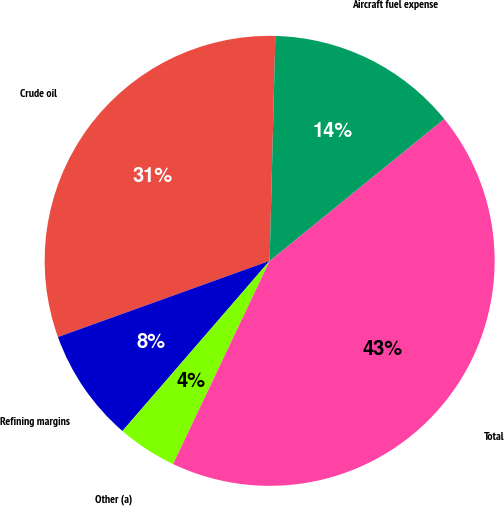Convert chart. <chart><loc_0><loc_0><loc_500><loc_500><pie_chart><fcel>Crude oil<fcel>Refining margins<fcel>Other (a)<fcel>Total<fcel>Aircraft fuel expense<nl><fcel>30.9%<fcel>8.15%<fcel>4.29%<fcel>42.92%<fcel>13.73%<nl></chart> 